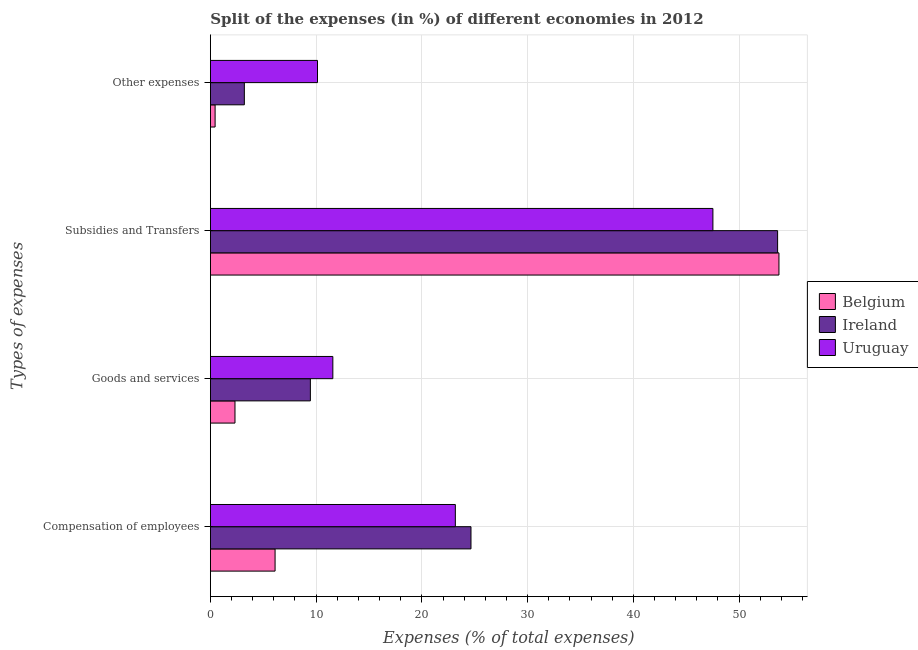How many groups of bars are there?
Provide a short and direct response. 4. Are the number of bars per tick equal to the number of legend labels?
Make the answer very short. Yes. What is the label of the 4th group of bars from the top?
Ensure brevity in your answer.  Compensation of employees. What is the percentage of amount spent on other expenses in Ireland?
Offer a very short reply. 3.21. Across all countries, what is the maximum percentage of amount spent on compensation of employees?
Provide a succinct answer. 24.64. Across all countries, what is the minimum percentage of amount spent on compensation of employees?
Your response must be concise. 6.12. In which country was the percentage of amount spent on goods and services maximum?
Your answer should be very brief. Uruguay. What is the total percentage of amount spent on goods and services in the graph?
Keep it short and to the point. 23.36. What is the difference between the percentage of amount spent on other expenses in Belgium and that in Uruguay?
Keep it short and to the point. -9.68. What is the difference between the percentage of amount spent on compensation of employees in Belgium and the percentage of amount spent on goods and services in Uruguay?
Your answer should be compact. -5.46. What is the average percentage of amount spent on goods and services per country?
Provide a succinct answer. 7.79. What is the difference between the percentage of amount spent on compensation of employees and percentage of amount spent on other expenses in Uruguay?
Your answer should be compact. 13.04. What is the ratio of the percentage of amount spent on compensation of employees in Uruguay to that in Belgium?
Offer a very short reply. 3.79. Is the percentage of amount spent on compensation of employees in Ireland less than that in Uruguay?
Provide a short and direct response. No. Is the difference between the percentage of amount spent on goods and services in Belgium and Uruguay greater than the difference between the percentage of amount spent on other expenses in Belgium and Uruguay?
Make the answer very short. Yes. What is the difference between the highest and the second highest percentage of amount spent on other expenses?
Provide a short and direct response. 6.92. What is the difference between the highest and the lowest percentage of amount spent on compensation of employees?
Ensure brevity in your answer.  18.53. Is the sum of the percentage of amount spent on other expenses in Uruguay and Belgium greater than the maximum percentage of amount spent on goods and services across all countries?
Provide a short and direct response. No. Is it the case that in every country, the sum of the percentage of amount spent on goods and services and percentage of amount spent on other expenses is greater than the sum of percentage of amount spent on compensation of employees and percentage of amount spent on subsidies?
Provide a short and direct response. No. What does the 2nd bar from the top in Other expenses represents?
Your response must be concise. Ireland. What does the 2nd bar from the bottom in Goods and services represents?
Give a very brief answer. Ireland. How many bars are there?
Ensure brevity in your answer.  12. What is the difference between two consecutive major ticks on the X-axis?
Make the answer very short. 10. Does the graph contain any zero values?
Ensure brevity in your answer.  No. Does the graph contain grids?
Give a very brief answer. Yes. Where does the legend appear in the graph?
Give a very brief answer. Center right. How are the legend labels stacked?
Your answer should be compact. Vertical. What is the title of the graph?
Offer a very short reply. Split of the expenses (in %) of different economies in 2012. What is the label or title of the X-axis?
Your response must be concise. Expenses (% of total expenses). What is the label or title of the Y-axis?
Offer a very short reply. Types of expenses. What is the Expenses (% of total expenses) in Belgium in Compensation of employees?
Your response must be concise. 6.12. What is the Expenses (% of total expenses) in Ireland in Compensation of employees?
Your answer should be very brief. 24.64. What is the Expenses (% of total expenses) of Uruguay in Compensation of employees?
Keep it short and to the point. 23.17. What is the Expenses (% of total expenses) in Belgium in Goods and services?
Offer a very short reply. 2.33. What is the Expenses (% of total expenses) of Ireland in Goods and services?
Keep it short and to the point. 9.46. What is the Expenses (% of total expenses) of Uruguay in Goods and services?
Your answer should be very brief. 11.58. What is the Expenses (% of total expenses) in Belgium in Subsidies and Transfers?
Give a very brief answer. 53.77. What is the Expenses (% of total expenses) of Ireland in Subsidies and Transfers?
Offer a very short reply. 53.64. What is the Expenses (% of total expenses) of Uruguay in Subsidies and Transfers?
Keep it short and to the point. 47.52. What is the Expenses (% of total expenses) of Belgium in Other expenses?
Offer a terse response. 0.45. What is the Expenses (% of total expenses) in Ireland in Other expenses?
Give a very brief answer. 3.21. What is the Expenses (% of total expenses) of Uruguay in Other expenses?
Give a very brief answer. 10.13. Across all Types of expenses, what is the maximum Expenses (% of total expenses) of Belgium?
Your answer should be compact. 53.77. Across all Types of expenses, what is the maximum Expenses (% of total expenses) in Ireland?
Keep it short and to the point. 53.64. Across all Types of expenses, what is the maximum Expenses (% of total expenses) in Uruguay?
Give a very brief answer. 47.52. Across all Types of expenses, what is the minimum Expenses (% of total expenses) of Belgium?
Your response must be concise. 0.45. Across all Types of expenses, what is the minimum Expenses (% of total expenses) in Ireland?
Provide a short and direct response. 3.21. Across all Types of expenses, what is the minimum Expenses (% of total expenses) of Uruguay?
Make the answer very short. 10.13. What is the total Expenses (% of total expenses) in Belgium in the graph?
Your response must be concise. 62.66. What is the total Expenses (% of total expenses) of Ireland in the graph?
Provide a short and direct response. 90.95. What is the total Expenses (% of total expenses) in Uruguay in the graph?
Provide a succinct answer. 92.4. What is the difference between the Expenses (% of total expenses) of Belgium in Compensation of employees and that in Goods and services?
Offer a very short reply. 3.79. What is the difference between the Expenses (% of total expenses) in Ireland in Compensation of employees and that in Goods and services?
Provide a short and direct response. 15.19. What is the difference between the Expenses (% of total expenses) in Uruguay in Compensation of employees and that in Goods and services?
Provide a short and direct response. 11.59. What is the difference between the Expenses (% of total expenses) of Belgium in Compensation of employees and that in Subsidies and Transfers?
Your answer should be compact. -47.65. What is the difference between the Expenses (% of total expenses) in Ireland in Compensation of employees and that in Subsidies and Transfers?
Ensure brevity in your answer.  -29. What is the difference between the Expenses (% of total expenses) in Uruguay in Compensation of employees and that in Subsidies and Transfers?
Keep it short and to the point. -24.36. What is the difference between the Expenses (% of total expenses) of Belgium in Compensation of employees and that in Other expenses?
Give a very brief answer. 5.67. What is the difference between the Expenses (% of total expenses) in Ireland in Compensation of employees and that in Other expenses?
Make the answer very short. 21.43. What is the difference between the Expenses (% of total expenses) of Uruguay in Compensation of employees and that in Other expenses?
Provide a succinct answer. 13.04. What is the difference between the Expenses (% of total expenses) in Belgium in Goods and services and that in Subsidies and Transfers?
Offer a terse response. -51.44. What is the difference between the Expenses (% of total expenses) in Ireland in Goods and services and that in Subsidies and Transfers?
Your answer should be very brief. -44.19. What is the difference between the Expenses (% of total expenses) in Uruguay in Goods and services and that in Subsidies and Transfers?
Your answer should be very brief. -35.94. What is the difference between the Expenses (% of total expenses) of Belgium in Goods and services and that in Other expenses?
Give a very brief answer. 1.88. What is the difference between the Expenses (% of total expenses) of Ireland in Goods and services and that in Other expenses?
Offer a terse response. 6.24. What is the difference between the Expenses (% of total expenses) in Uruguay in Goods and services and that in Other expenses?
Provide a succinct answer. 1.45. What is the difference between the Expenses (% of total expenses) in Belgium in Subsidies and Transfers and that in Other expenses?
Provide a succinct answer. 53.32. What is the difference between the Expenses (% of total expenses) of Ireland in Subsidies and Transfers and that in Other expenses?
Give a very brief answer. 50.43. What is the difference between the Expenses (% of total expenses) in Uruguay in Subsidies and Transfers and that in Other expenses?
Make the answer very short. 37.4. What is the difference between the Expenses (% of total expenses) in Belgium in Compensation of employees and the Expenses (% of total expenses) in Ireland in Goods and services?
Your answer should be compact. -3.34. What is the difference between the Expenses (% of total expenses) in Belgium in Compensation of employees and the Expenses (% of total expenses) in Uruguay in Goods and services?
Your answer should be compact. -5.46. What is the difference between the Expenses (% of total expenses) of Ireland in Compensation of employees and the Expenses (% of total expenses) of Uruguay in Goods and services?
Provide a short and direct response. 13.06. What is the difference between the Expenses (% of total expenses) of Belgium in Compensation of employees and the Expenses (% of total expenses) of Ireland in Subsidies and Transfers?
Offer a very short reply. -47.52. What is the difference between the Expenses (% of total expenses) in Belgium in Compensation of employees and the Expenses (% of total expenses) in Uruguay in Subsidies and Transfers?
Give a very brief answer. -41.41. What is the difference between the Expenses (% of total expenses) in Ireland in Compensation of employees and the Expenses (% of total expenses) in Uruguay in Subsidies and Transfers?
Your answer should be very brief. -22.88. What is the difference between the Expenses (% of total expenses) in Belgium in Compensation of employees and the Expenses (% of total expenses) in Ireland in Other expenses?
Provide a succinct answer. 2.91. What is the difference between the Expenses (% of total expenses) of Belgium in Compensation of employees and the Expenses (% of total expenses) of Uruguay in Other expenses?
Your response must be concise. -4.01. What is the difference between the Expenses (% of total expenses) of Ireland in Compensation of employees and the Expenses (% of total expenses) of Uruguay in Other expenses?
Offer a very short reply. 14.52. What is the difference between the Expenses (% of total expenses) of Belgium in Goods and services and the Expenses (% of total expenses) of Ireland in Subsidies and Transfers?
Provide a succinct answer. -51.32. What is the difference between the Expenses (% of total expenses) of Belgium in Goods and services and the Expenses (% of total expenses) of Uruguay in Subsidies and Transfers?
Provide a succinct answer. -45.2. What is the difference between the Expenses (% of total expenses) in Ireland in Goods and services and the Expenses (% of total expenses) in Uruguay in Subsidies and Transfers?
Offer a very short reply. -38.07. What is the difference between the Expenses (% of total expenses) of Belgium in Goods and services and the Expenses (% of total expenses) of Ireland in Other expenses?
Give a very brief answer. -0.89. What is the difference between the Expenses (% of total expenses) in Belgium in Goods and services and the Expenses (% of total expenses) in Uruguay in Other expenses?
Make the answer very short. -7.8. What is the difference between the Expenses (% of total expenses) of Ireland in Goods and services and the Expenses (% of total expenses) of Uruguay in Other expenses?
Offer a terse response. -0.67. What is the difference between the Expenses (% of total expenses) in Belgium in Subsidies and Transfers and the Expenses (% of total expenses) in Ireland in Other expenses?
Provide a short and direct response. 50.56. What is the difference between the Expenses (% of total expenses) of Belgium in Subsidies and Transfers and the Expenses (% of total expenses) of Uruguay in Other expenses?
Provide a succinct answer. 43.64. What is the difference between the Expenses (% of total expenses) in Ireland in Subsidies and Transfers and the Expenses (% of total expenses) in Uruguay in Other expenses?
Provide a short and direct response. 43.51. What is the average Expenses (% of total expenses) of Belgium per Types of expenses?
Offer a very short reply. 15.66. What is the average Expenses (% of total expenses) of Ireland per Types of expenses?
Your answer should be compact. 22.74. What is the average Expenses (% of total expenses) in Uruguay per Types of expenses?
Give a very brief answer. 23.1. What is the difference between the Expenses (% of total expenses) of Belgium and Expenses (% of total expenses) of Ireland in Compensation of employees?
Your response must be concise. -18.53. What is the difference between the Expenses (% of total expenses) in Belgium and Expenses (% of total expenses) in Uruguay in Compensation of employees?
Give a very brief answer. -17.05. What is the difference between the Expenses (% of total expenses) in Ireland and Expenses (% of total expenses) in Uruguay in Compensation of employees?
Provide a succinct answer. 1.48. What is the difference between the Expenses (% of total expenses) in Belgium and Expenses (% of total expenses) in Ireland in Goods and services?
Provide a short and direct response. -7.13. What is the difference between the Expenses (% of total expenses) of Belgium and Expenses (% of total expenses) of Uruguay in Goods and services?
Give a very brief answer. -9.25. What is the difference between the Expenses (% of total expenses) of Ireland and Expenses (% of total expenses) of Uruguay in Goods and services?
Your answer should be compact. -2.12. What is the difference between the Expenses (% of total expenses) in Belgium and Expenses (% of total expenses) in Ireland in Subsidies and Transfers?
Offer a terse response. 0.13. What is the difference between the Expenses (% of total expenses) in Belgium and Expenses (% of total expenses) in Uruguay in Subsidies and Transfers?
Provide a short and direct response. 6.25. What is the difference between the Expenses (% of total expenses) of Ireland and Expenses (% of total expenses) of Uruguay in Subsidies and Transfers?
Give a very brief answer. 6.12. What is the difference between the Expenses (% of total expenses) of Belgium and Expenses (% of total expenses) of Ireland in Other expenses?
Offer a very short reply. -2.77. What is the difference between the Expenses (% of total expenses) of Belgium and Expenses (% of total expenses) of Uruguay in Other expenses?
Your answer should be very brief. -9.68. What is the difference between the Expenses (% of total expenses) in Ireland and Expenses (% of total expenses) in Uruguay in Other expenses?
Provide a succinct answer. -6.92. What is the ratio of the Expenses (% of total expenses) of Belgium in Compensation of employees to that in Goods and services?
Offer a terse response. 2.63. What is the ratio of the Expenses (% of total expenses) in Ireland in Compensation of employees to that in Goods and services?
Your answer should be compact. 2.61. What is the ratio of the Expenses (% of total expenses) of Uruguay in Compensation of employees to that in Goods and services?
Provide a succinct answer. 2. What is the ratio of the Expenses (% of total expenses) in Belgium in Compensation of employees to that in Subsidies and Transfers?
Your response must be concise. 0.11. What is the ratio of the Expenses (% of total expenses) of Ireland in Compensation of employees to that in Subsidies and Transfers?
Provide a short and direct response. 0.46. What is the ratio of the Expenses (% of total expenses) of Uruguay in Compensation of employees to that in Subsidies and Transfers?
Your response must be concise. 0.49. What is the ratio of the Expenses (% of total expenses) in Belgium in Compensation of employees to that in Other expenses?
Make the answer very short. 13.71. What is the ratio of the Expenses (% of total expenses) of Ireland in Compensation of employees to that in Other expenses?
Provide a short and direct response. 7.67. What is the ratio of the Expenses (% of total expenses) in Uruguay in Compensation of employees to that in Other expenses?
Provide a short and direct response. 2.29. What is the ratio of the Expenses (% of total expenses) in Belgium in Goods and services to that in Subsidies and Transfers?
Your answer should be compact. 0.04. What is the ratio of the Expenses (% of total expenses) in Ireland in Goods and services to that in Subsidies and Transfers?
Offer a very short reply. 0.18. What is the ratio of the Expenses (% of total expenses) in Uruguay in Goods and services to that in Subsidies and Transfers?
Give a very brief answer. 0.24. What is the ratio of the Expenses (% of total expenses) of Belgium in Goods and services to that in Other expenses?
Provide a succinct answer. 5.21. What is the ratio of the Expenses (% of total expenses) of Ireland in Goods and services to that in Other expenses?
Your response must be concise. 2.94. What is the ratio of the Expenses (% of total expenses) of Uruguay in Goods and services to that in Other expenses?
Make the answer very short. 1.14. What is the ratio of the Expenses (% of total expenses) of Belgium in Subsidies and Transfers to that in Other expenses?
Your answer should be very brief. 120.46. What is the ratio of the Expenses (% of total expenses) of Ireland in Subsidies and Transfers to that in Other expenses?
Offer a very short reply. 16.7. What is the ratio of the Expenses (% of total expenses) of Uruguay in Subsidies and Transfers to that in Other expenses?
Make the answer very short. 4.69. What is the difference between the highest and the second highest Expenses (% of total expenses) of Belgium?
Provide a short and direct response. 47.65. What is the difference between the highest and the second highest Expenses (% of total expenses) of Ireland?
Your response must be concise. 29. What is the difference between the highest and the second highest Expenses (% of total expenses) of Uruguay?
Make the answer very short. 24.36. What is the difference between the highest and the lowest Expenses (% of total expenses) in Belgium?
Ensure brevity in your answer.  53.32. What is the difference between the highest and the lowest Expenses (% of total expenses) of Ireland?
Your answer should be compact. 50.43. What is the difference between the highest and the lowest Expenses (% of total expenses) in Uruguay?
Make the answer very short. 37.4. 